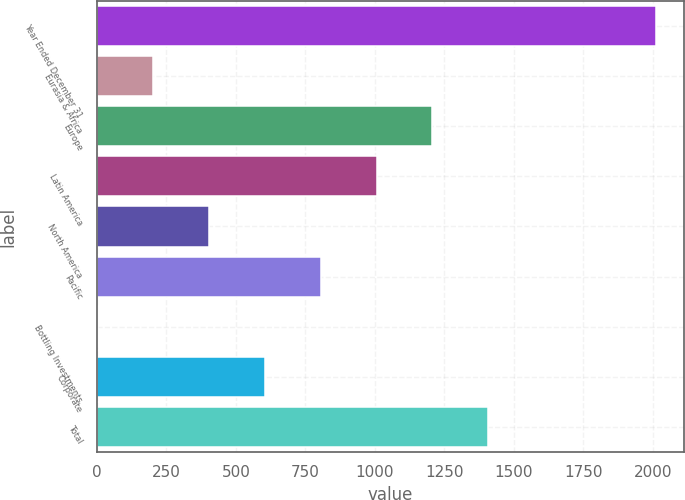<chart> <loc_0><loc_0><loc_500><loc_500><bar_chart><fcel>Year Ended December 31<fcel>Eurasia & Africa<fcel>Europe<fcel>Latin America<fcel>North America<fcel>Pacific<fcel>Bottling Investments<fcel>Corporate<fcel>Total<nl><fcel>2010<fcel>203.43<fcel>1207.08<fcel>1006.35<fcel>404.16<fcel>805.62<fcel>2.7<fcel>604.89<fcel>1407.81<nl></chart> 